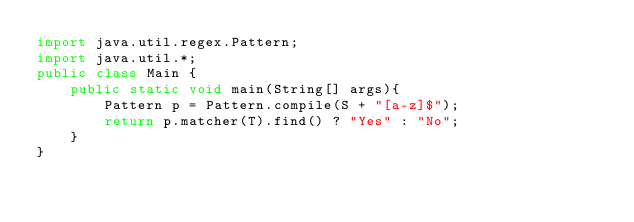<code> <loc_0><loc_0><loc_500><loc_500><_Java_>import java.util.regex.Pattern;
import java.util.*;
public class Main {
    public static void main(String[] args){
		Pattern p = Pattern.compile(S + "[a-z]$");
		return p.matcher(T).find() ? "Yes" : "No";
    }
}</code> 